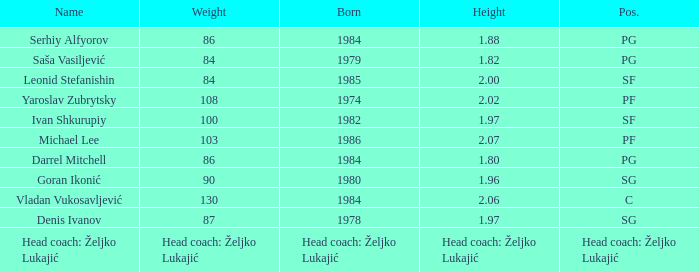What is the weight of the person born in 1980? 90.0. 